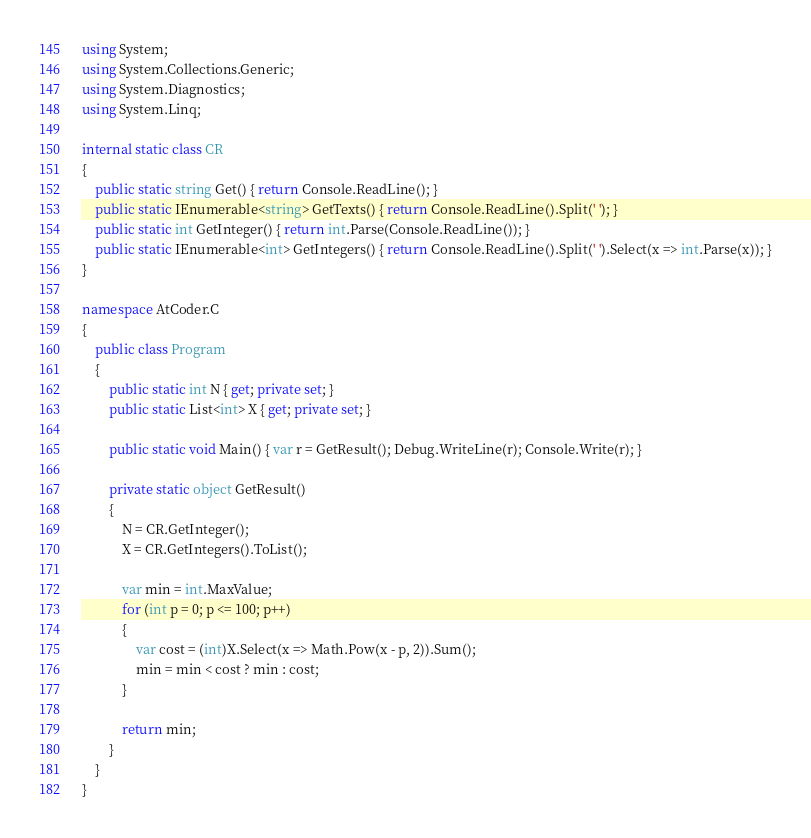Convert code to text. <code><loc_0><loc_0><loc_500><loc_500><_C#_>using System;
using System.Collections.Generic;
using System.Diagnostics;
using System.Linq;

internal static class CR
{
    public static string Get() { return Console.ReadLine(); }
    public static IEnumerable<string> GetTexts() { return Console.ReadLine().Split(' '); }
    public static int GetInteger() { return int.Parse(Console.ReadLine()); }
    public static IEnumerable<int> GetIntegers() { return Console.ReadLine().Split(' ').Select(x => int.Parse(x)); }
}

namespace AtCoder.C
{
    public class Program
    {
        public static int N { get; private set; }
        public static List<int> X { get; private set; }

        public static void Main() { var r = GetResult(); Debug.WriteLine(r); Console.Write(r); }

        private static object GetResult()
        {
            N = CR.GetInteger();
            X = CR.GetIntegers().ToList();

            var min = int.MaxValue;
            for (int p = 0; p <= 100; p++)
            {
                var cost = (int)X.Select(x => Math.Pow(x - p, 2)).Sum();
                min = min < cost ? min : cost;
            }

            return min;
        }
    }
}
</code> 